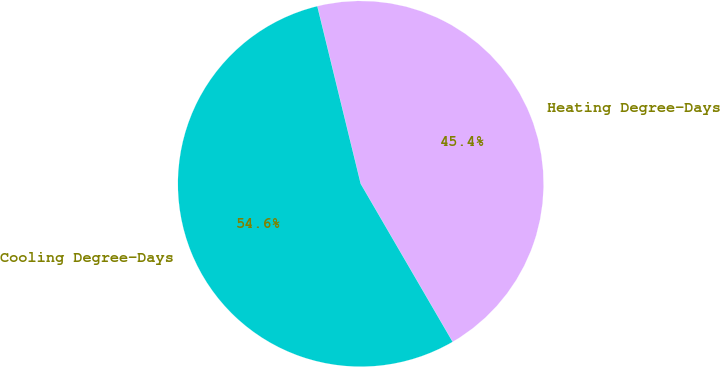Convert chart. <chart><loc_0><loc_0><loc_500><loc_500><pie_chart><fcel>Heating Degree-Days<fcel>Cooling Degree-Days<nl><fcel>45.43%<fcel>54.57%<nl></chart> 